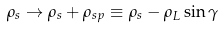<formula> <loc_0><loc_0><loc_500><loc_500>\rho _ { s } \rightarrow \rho _ { s } + \rho _ { s p } \equiv \rho _ { s } - \rho _ { L } \sin \gamma</formula> 